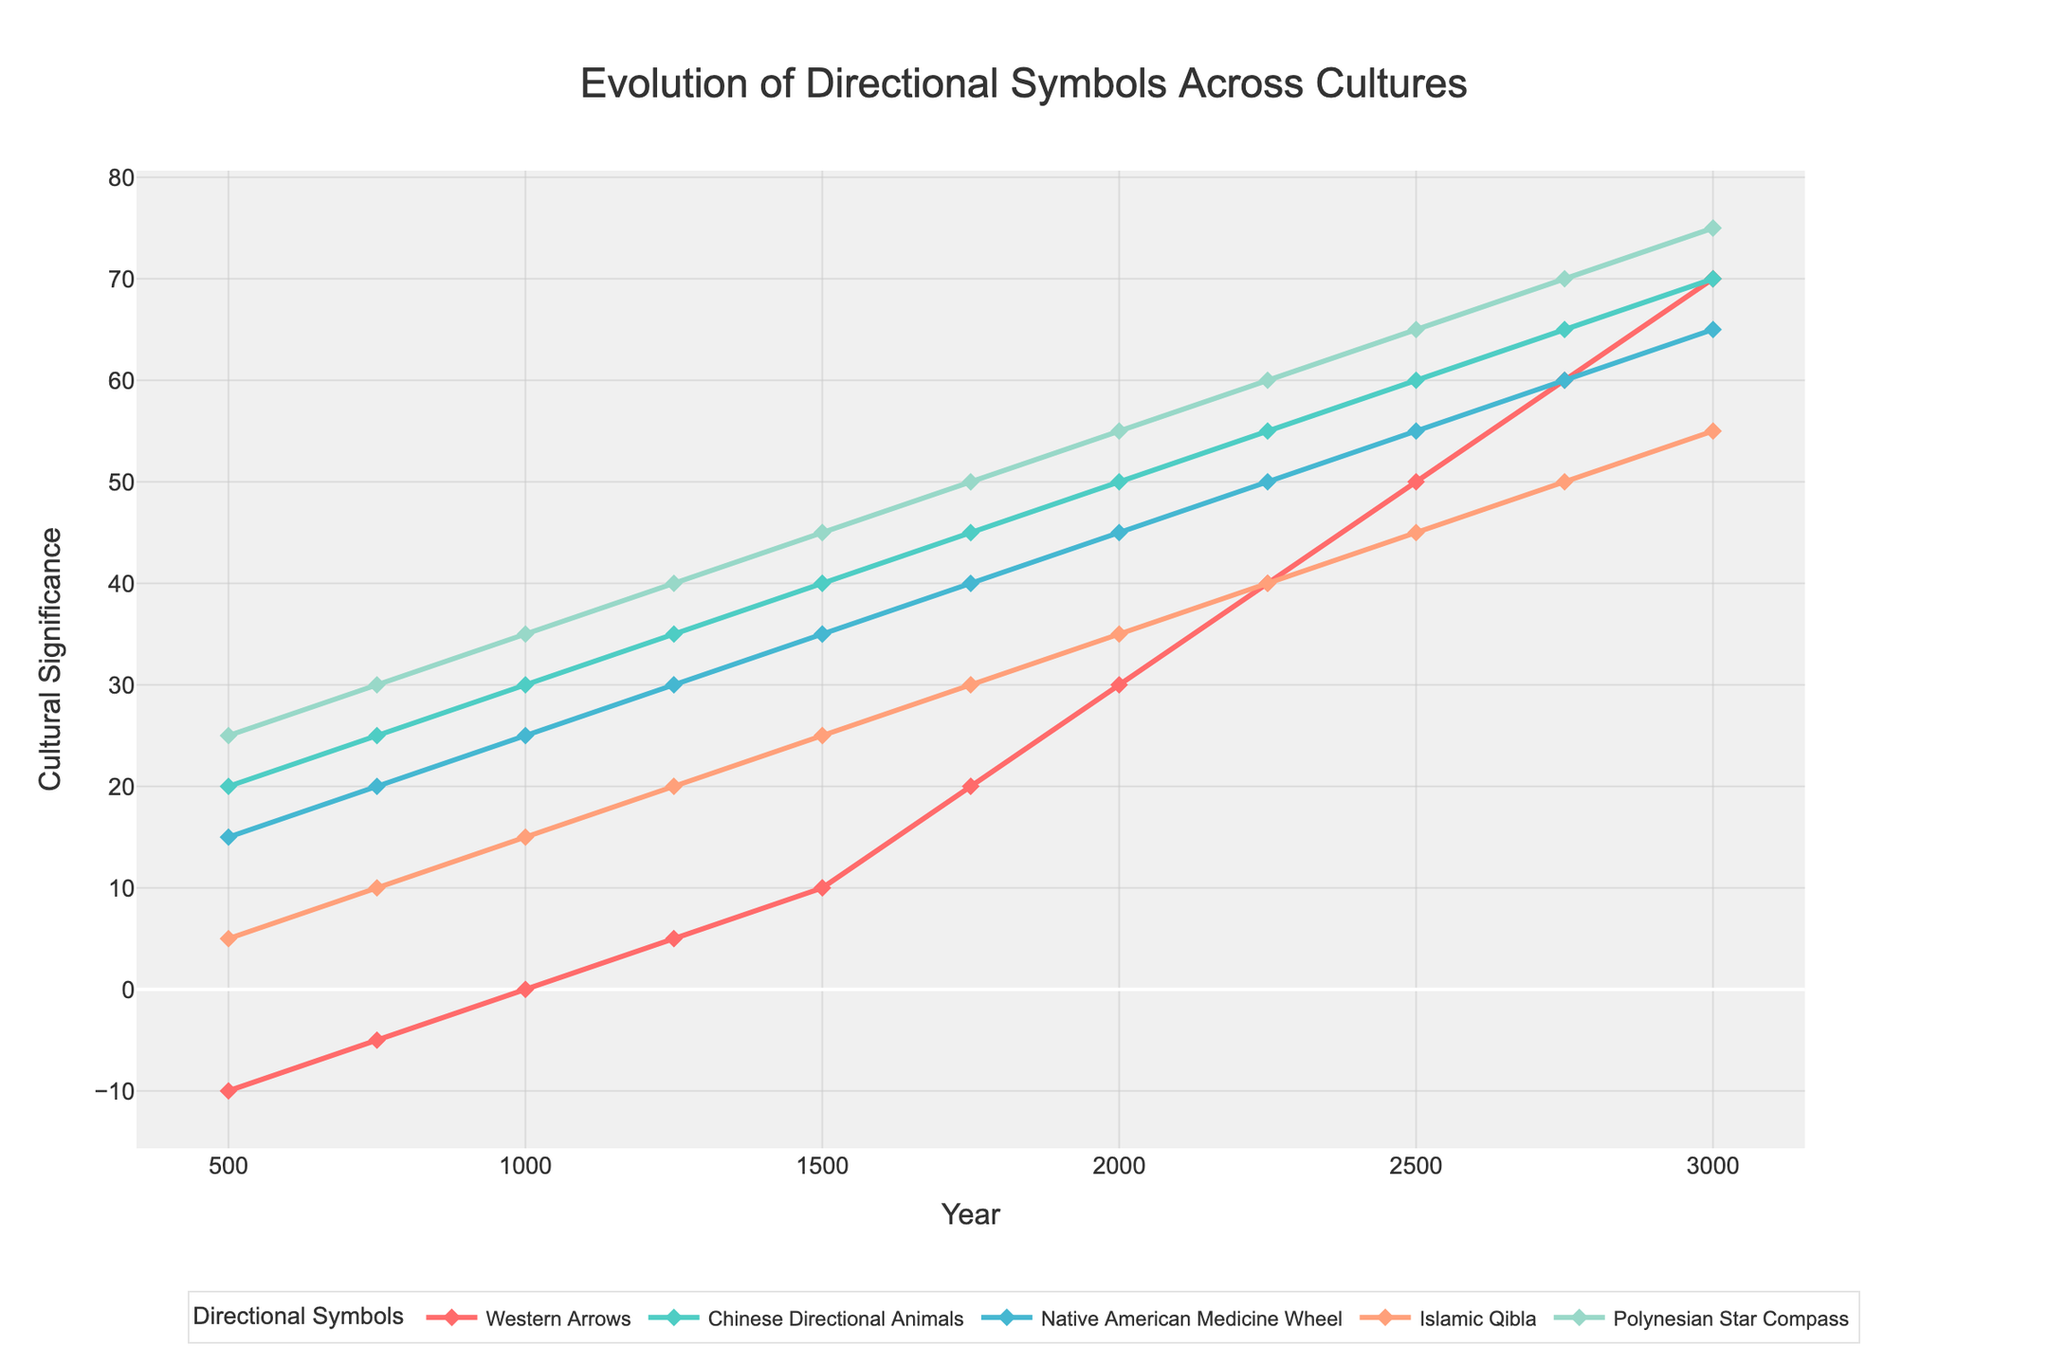What is the value of Western Arrows in the year 2000? To find the value of Western Arrows in the year 2000, locate the year 2000 on the x-axis and trace upwards to the corresponding point on the Western Arrows line (in red). The y-value at this point gives the required value.
Answer: 30 Which directional symbol had the highest value in the year 1500? To determine the highest value in the year 1500, locate the year 1500 on the x-axis and compare the y-values for all directional symbols at this point. The highest y-value represents the directional symbol with the highest value.
Answer: Polynesian Star Compass How did the Chinese Directional Animals change from the year 500 to 1000? Look at the y-values for the Chinese Directional Animals (shown in green) at the years 500 and 1000. Subtract the value for 500 from the value for 1000.
Answer: Increased by 10 What is the difference in cultural significance for the Native American Medicine Wheel between the years 1250 and 1750? Locate the y-values for the Native American Medicine Wheel (shown in teal) at the years 1250 and 1750. Subtract the value at 1250 from the value at 1750.
Answer: Increased by 10 Among the directional symbols, which one showed the most consistent increase over time? Assess the trend lines for each symbol and identify the one with the most uniform slope. The directional symbol with the most consistent increase is noted.
Answer: Polynesian Star Compass At what year did Islamic Qibla surpass the Western Arrows in cultural significance? Observe the points where the Islamic Qibla (orange line) crosses above the Western Arrows (red line). Identify the smallest year at which this occurs.
Answer: Around 1750 Describe the trend for the Native American Medicine Wheel from 500 to 3000. Identify the starting and ending points of the Native American Medicine Wheel line (teal), and observe the overall direction and rate of change over time. The trend is a steady increase.
Answer: Steady increase Which symbol had the lowest value in the year 500? Check the y-values for each directional symbol at the year 500, and determine the one with the lowest value.
Answer: Western Arrows How many increments of 20 can be found in the Western Arrows values between the years 500 and 3000? Observe the y-values for the Western Arrows (red line). Count the number of 20-unit intervals between the earliest value at 500 (-10) and the latest at 3000 (70).
Answer: 4 increments Compare the increase in cultural significance for the Chinese Directional Animals and Polynesian Star Compass from 1000 to 3000. Find the y-values for each symbol at 1000 and 3000. For Chinese Directional Animals: 70 - 30 = 40. For Polynesian Star Compass: 75 - 35 = 40. Both have the same increase.
Answer: Same increase 